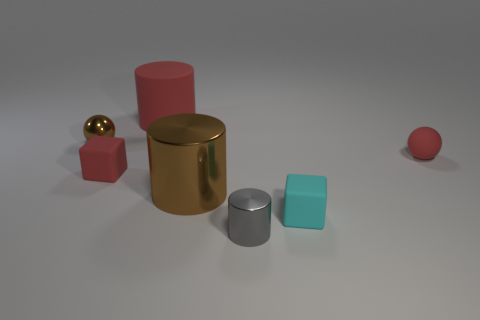Subtract all gray cylinders. How many cylinders are left? 2 Add 3 large red cylinders. How many objects exist? 10 Subtract all red balls. How many balls are left? 1 Subtract all cylinders. How many objects are left? 4 Subtract 1 balls. How many balls are left? 1 Subtract all gray blocks. Subtract all blue cylinders. How many blocks are left? 2 Subtract all purple spheres. How many yellow cylinders are left? 0 Subtract all big green metallic blocks. Subtract all small objects. How many objects are left? 2 Add 7 red spheres. How many red spheres are left? 8 Add 2 spheres. How many spheres exist? 4 